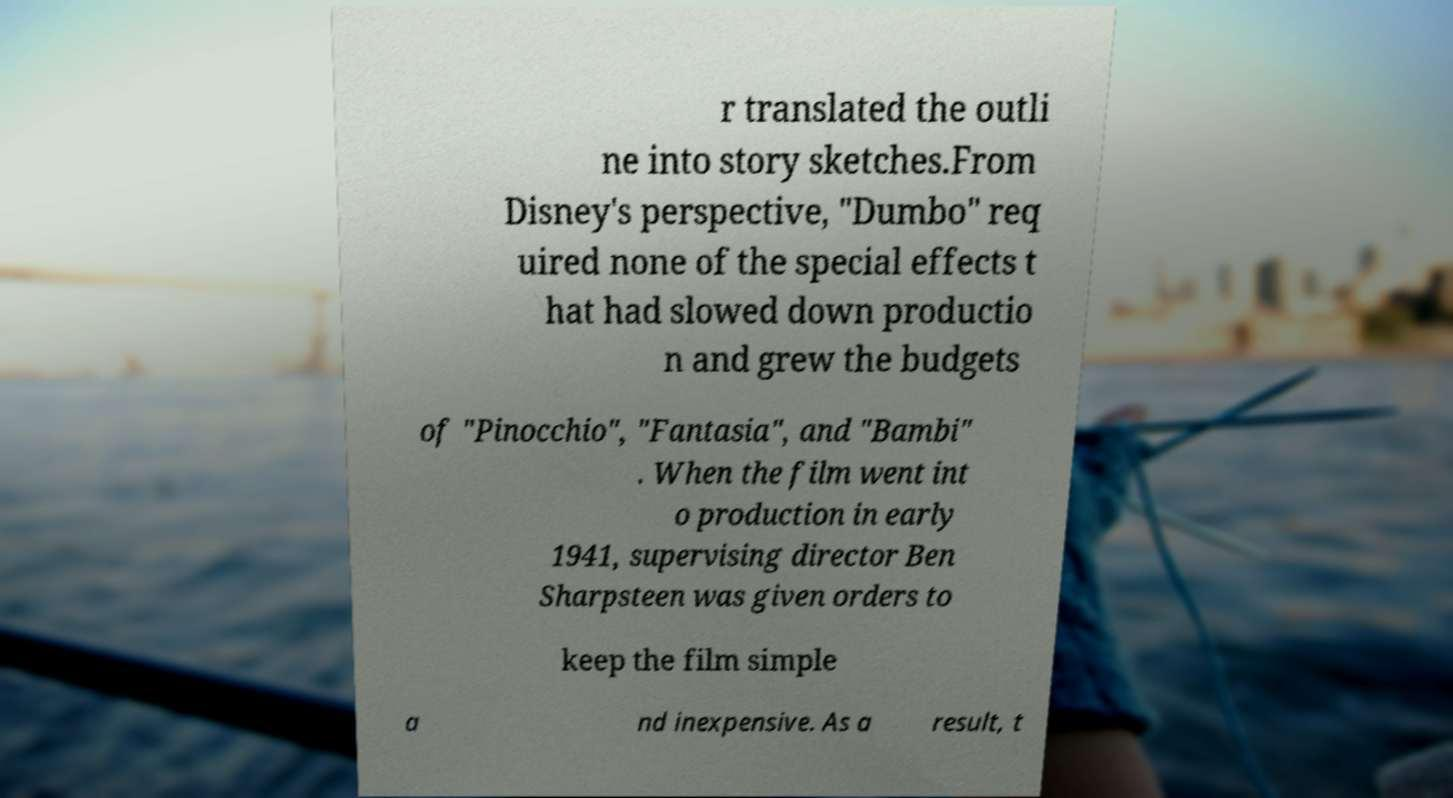Please identify and transcribe the text found in this image. r translated the outli ne into story sketches.From Disney's perspective, "Dumbo" req uired none of the special effects t hat had slowed down productio n and grew the budgets of "Pinocchio", "Fantasia", and "Bambi" . When the film went int o production in early 1941, supervising director Ben Sharpsteen was given orders to keep the film simple a nd inexpensive. As a result, t 